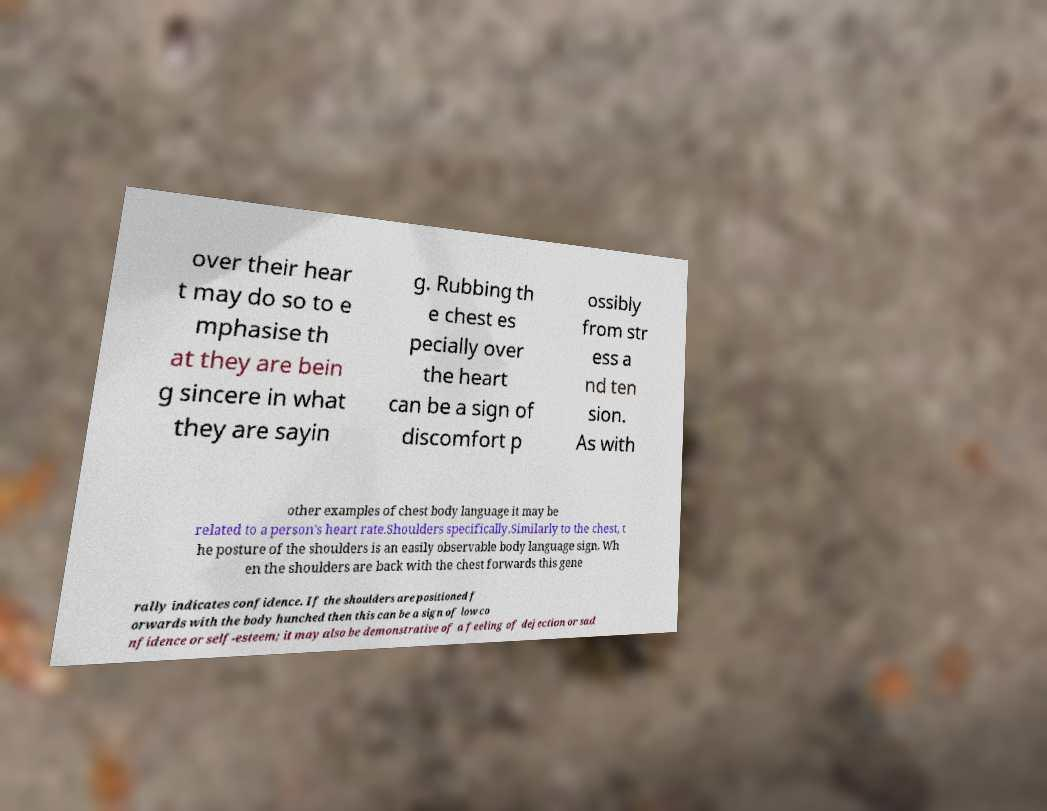For documentation purposes, I need the text within this image transcribed. Could you provide that? over their hear t may do so to e mphasise th at they are bein g sincere in what they are sayin g. Rubbing th e chest es pecially over the heart can be a sign of discomfort p ossibly from str ess a nd ten sion. As with other examples of chest body language it may be related to a person's heart rate.Shoulders specifically.Similarly to the chest, t he posture of the shoulders is an easily observable body language sign. Wh en the shoulders are back with the chest forwards this gene rally indicates confidence. If the shoulders are positioned f orwards with the body hunched then this can be a sign of low co nfidence or self-esteem; it may also be demonstrative of a feeling of dejection or sad 